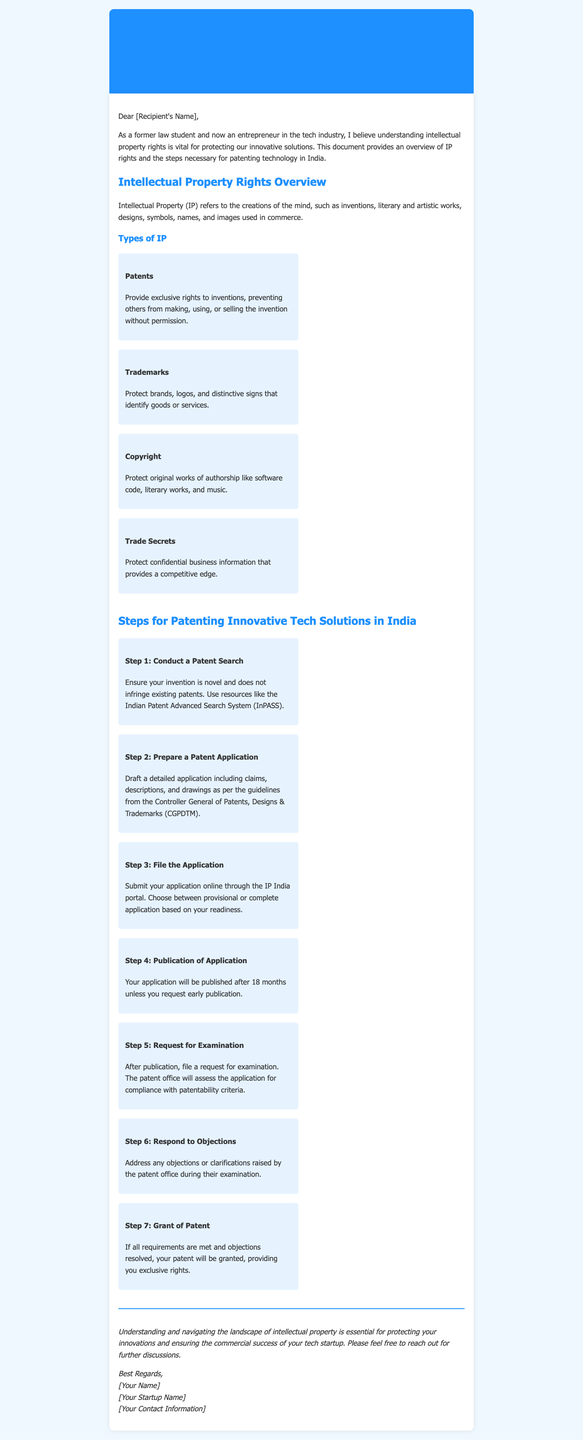What are the four types of intellectual property mentioned? The document lists four types of intellectual property: Patents, Trademarks, Copyright, and Trade Secrets.
Answer: Patents, Trademarks, Copyright, Trade Secrets What is the purpose of a patent? The document states that patents provide exclusive rights to inventions, preventing others from making, using, or selling the invention without permission.
Answer: Exclusive rights to inventions What is the first step in the patenting process? The document indicates that the first step is to conduct a patent search to ensure the invention is novel.
Answer: Conduct a Patent Search How long will it take for the application to be published without an early request? The document specifies that the application will be published after 18 months unless an early publication is requested.
Answer: 18 months What should be included in the patent application? The document mentions that the patent application should include claims, descriptions, and drawings as per the guidelines from the Controller General of Patents.
Answer: Claims, descriptions, and drawings What is the final step in the patenting process? The document concludes that if all requirements are met and objections resolved, the patent will be granted.
Answer: Grant of Patent Who should you contact for further discussions as per the document? The document suggests reaching out to the author of the email for further discussions.
Answer: Author of the email Which entity's guidelines should be followed when preparing a patent application? The document states that the guidelines from the Controller General of Patents, Designs & Trademarks should be followed.
Answer: Controller General of Patents, Designs & Trademarks 